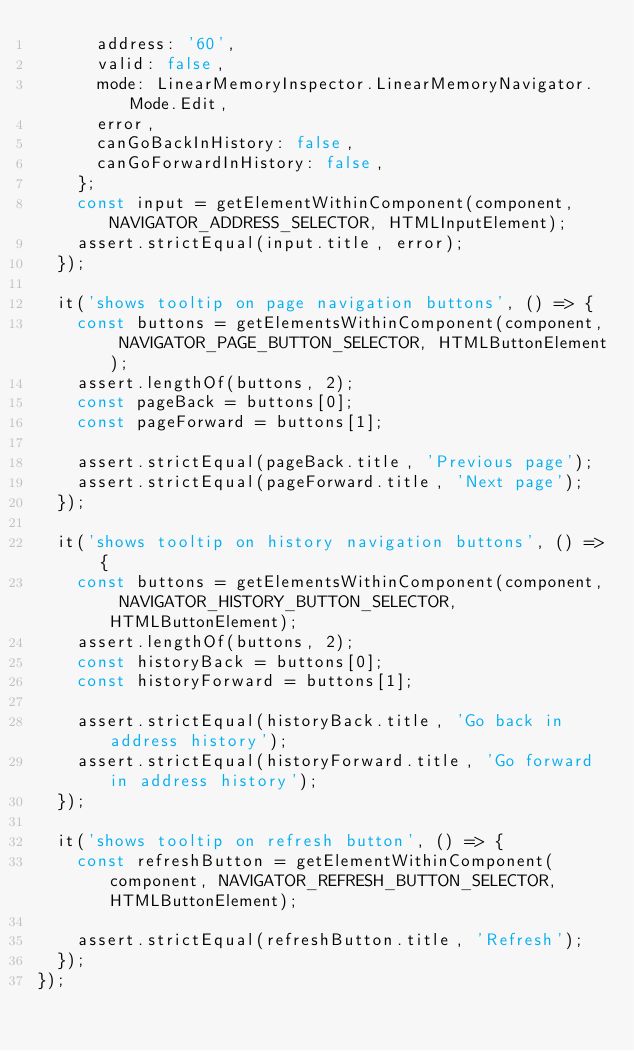Convert code to text. <code><loc_0><loc_0><loc_500><loc_500><_TypeScript_>      address: '60',
      valid: false,
      mode: LinearMemoryInspector.LinearMemoryNavigator.Mode.Edit,
      error,
      canGoBackInHistory: false,
      canGoForwardInHistory: false,
    };
    const input = getElementWithinComponent(component, NAVIGATOR_ADDRESS_SELECTOR, HTMLInputElement);
    assert.strictEqual(input.title, error);
  });

  it('shows tooltip on page navigation buttons', () => {
    const buttons = getElementsWithinComponent(component, NAVIGATOR_PAGE_BUTTON_SELECTOR, HTMLButtonElement);
    assert.lengthOf(buttons, 2);
    const pageBack = buttons[0];
    const pageForward = buttons[1];

    assert.strictEqual(pageBack.title, 'Previous page');
    assert.strictEqual(pageForward.title, 'Next page');
  });

  it('shows tooltip on history navigation buttons', () => {
    const buttons = getElementsWithinComponent(component, NAVIGATOR_HISTORY_BUTTON_SELECTOR, HTMLButtonElement);
    assert.lengthOf(buttons, 2);
    const historyBack = buttons[0];
    const historyForward = buttons[1];

    assert.strictEqual(historyBack.title, 'Go back in address history');
    assert.strictEqual(historyForward.title, 'Go forward in address history');
  });

  it('shows tooltip on refresh button', () => {
    const refreshButton = getElementWithinComponent(component, NAVIGATOR_REFRESH_BUTTON_SELECTOR, HTMLButtonElement);

    assert.strictEqual(refreshButton.title, 'Refresh');
  });
});
</code> 